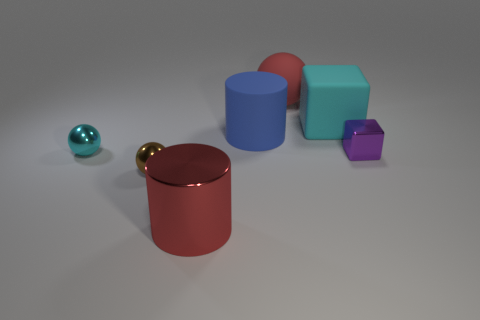Subtract all tiny cyan spheres. How many spheres are left? 2 Add 1 small gray metal balls. How many objects exist? 8 Subtract all purple blocks. How many blocks are left? 1 Subtract all spheres. How many objects are left? 4 Subtract 2 spheres. How many spheres are left? 1 Subtract all red balls. Subtract all red cubes. How many balls are left? 2 Subtract all blue cylinders. Subtract all large rubber balls. How many objects are left? 5 Add 4 cyan blocks. How many cyan blocks are left? 5 Add 3 big red balls. How many big red balls exist? 4 Subtract 0 red cubes. How many objects are left? 7 